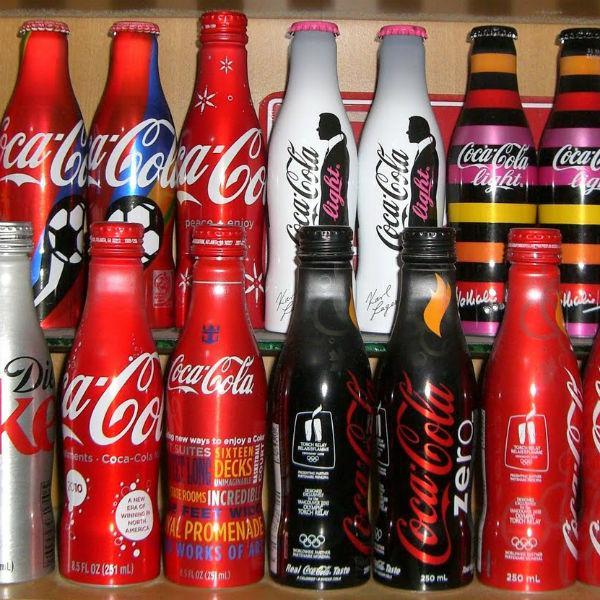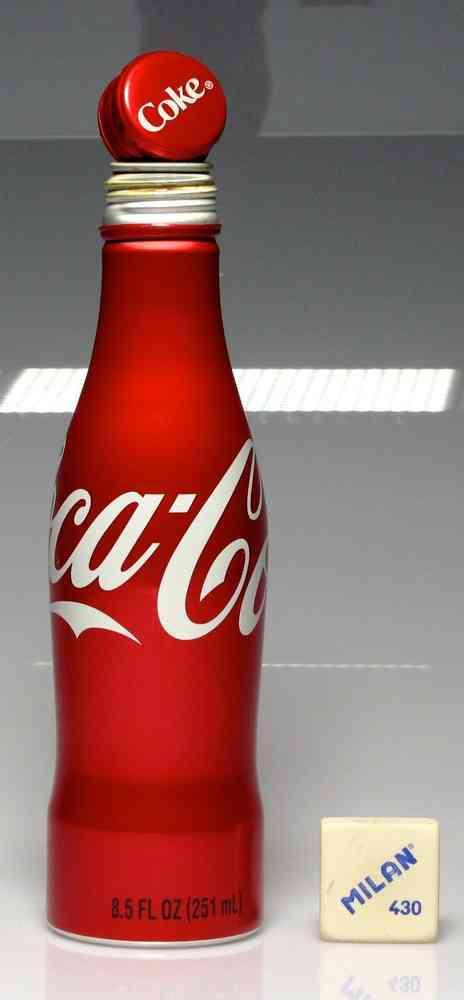The first image is the image on the left, the second image is the image on the right. Analyze the images presented: Is the assertion "Each image includes at least one bottle that is bright red with writing in white script letters around its middle." valid? Answer yes or no. Yes. 